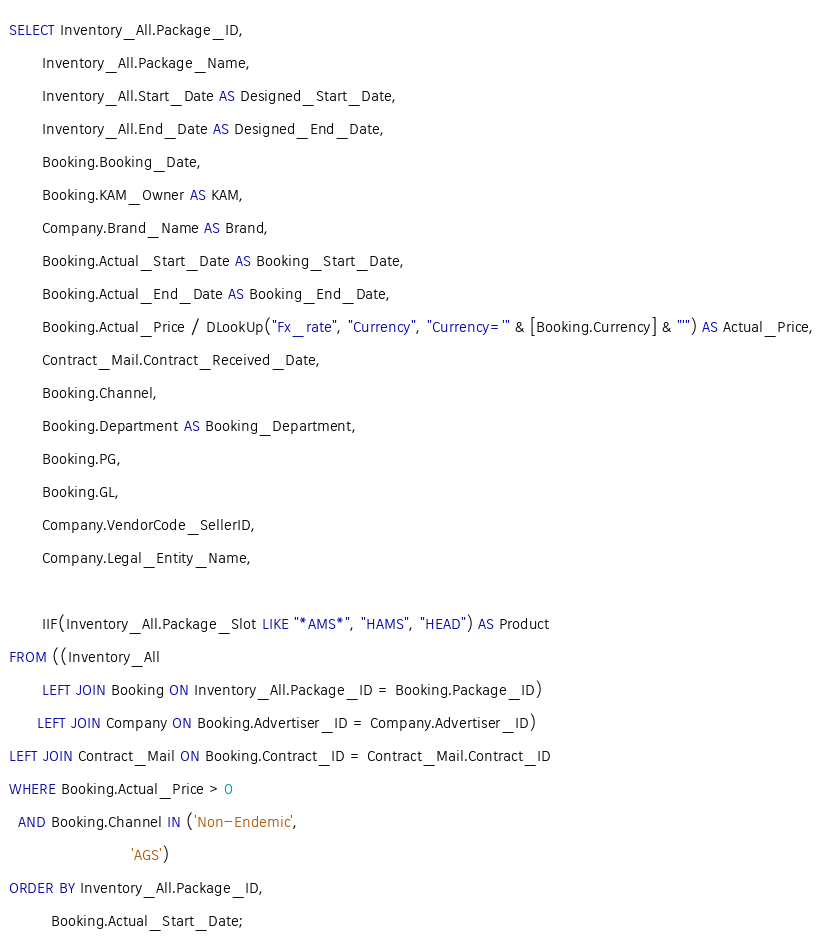Convert code to text. <code><loc_0><loc_0><loc_500><loc_500><_SQL_>SELECT Inventory_All.Package_ID,
       Inventory_All.Package_Name,
       Inventory_All.Start_Date AS Designed_Start_Date,
       Inventory_All.End_Date AS Designed_End_Date,
       Booking.Booking_Date,
       Booking.KAM_Owner AS KAM,
       Company.Brand_Name AS Brand,
       Booking.Actual_Start_Date AS Booking_Start_Date,
       Booking.Actual_End_Date AS Booking_End_Date,
       Booking.Actual_Price / DLookUp("Fx_rate", "Currency", "Currency='" & [Booking.Currency] & "'") AS Actual_Price,
       Contract_Mail.Contract_Received_Date,
       Booking.Channel,
       Booking.Department AS Booking_Department,
       Booking.PG,
       Booking.GL,
       Company.VendorCode_SellerID,
       Company.Legal_Entity_Name,
       
       IIF(Inventory_All.Package_Slot LIKE "*AMS*", "HAMS", "HEAD") AS Product
FROM ((Inventory_All
       LEFT JOIN Booking ON Inventory_All.Package_ID = Booking.Package_ID)
      LEFT JOIN Company ON Booking.Advertiser_ID = Company.Advertiser_ID)
LEFT JOIN Contract_Mail ON Booking.Contract_ID = Contract_Mail.Contract_ID
WHERE Booking.Actual_Price > 0
  AND Booking.Channel IN ('Non-Endemic',
                          'AGS')
ORDER BY Inventory_All.Package_ID,
         Booking.Actual_Start_Date;</code> 